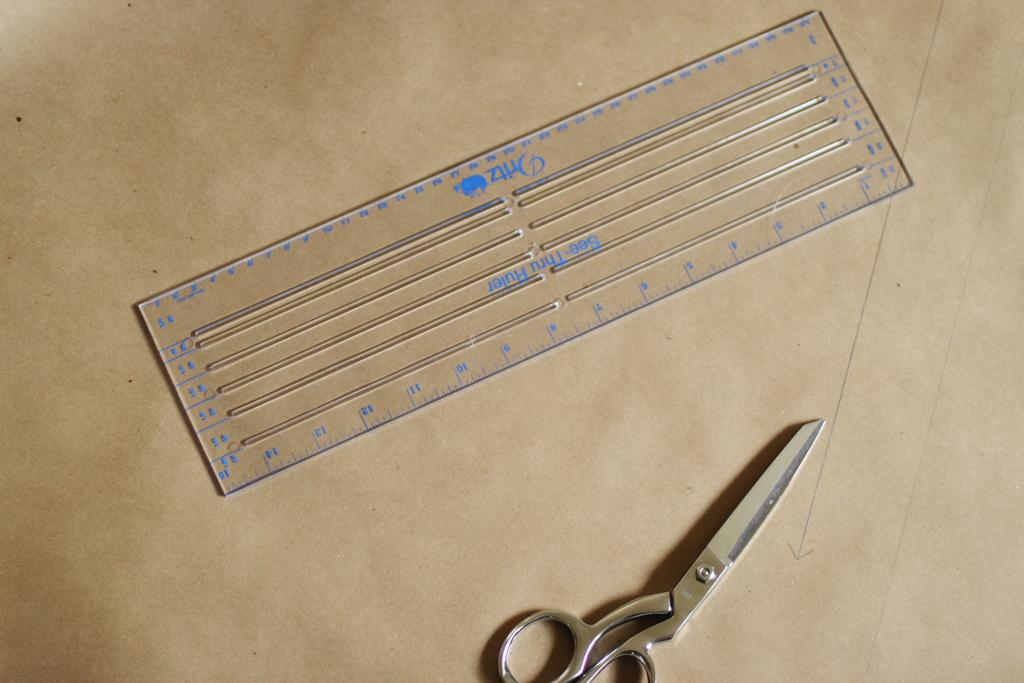<image>
Present a compact description of the photo's key features. the word see is on the blue and clear ruler 